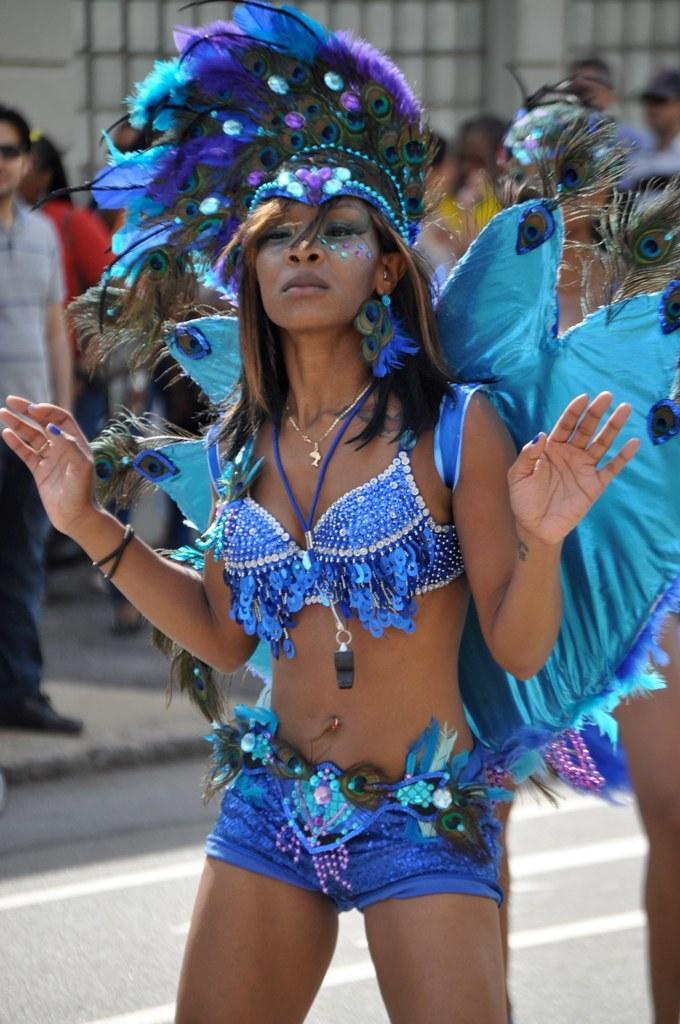Please provide a concise description of this image. In this image a woman wearing a crown is dancing on the road. Few persons are standing on the pavement. Behind them there is a wall. 